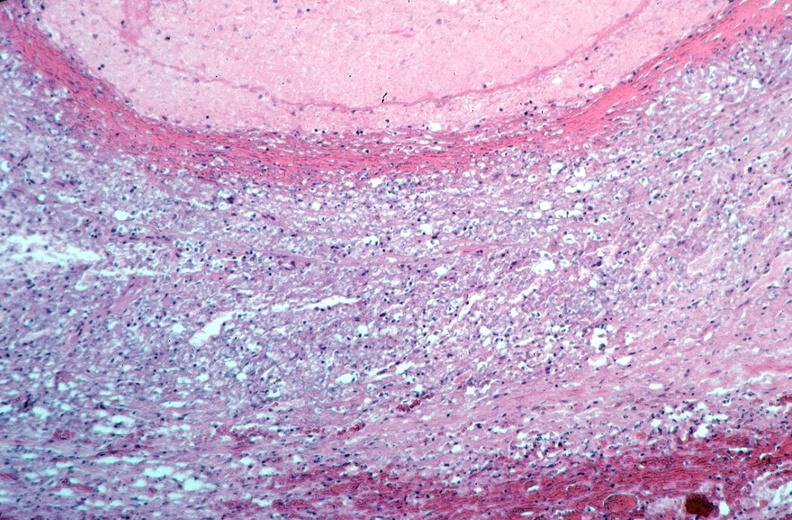does this image show vasculitis, polyarteritis nodosa?
Answer the question using a single word or phrase. Yes 